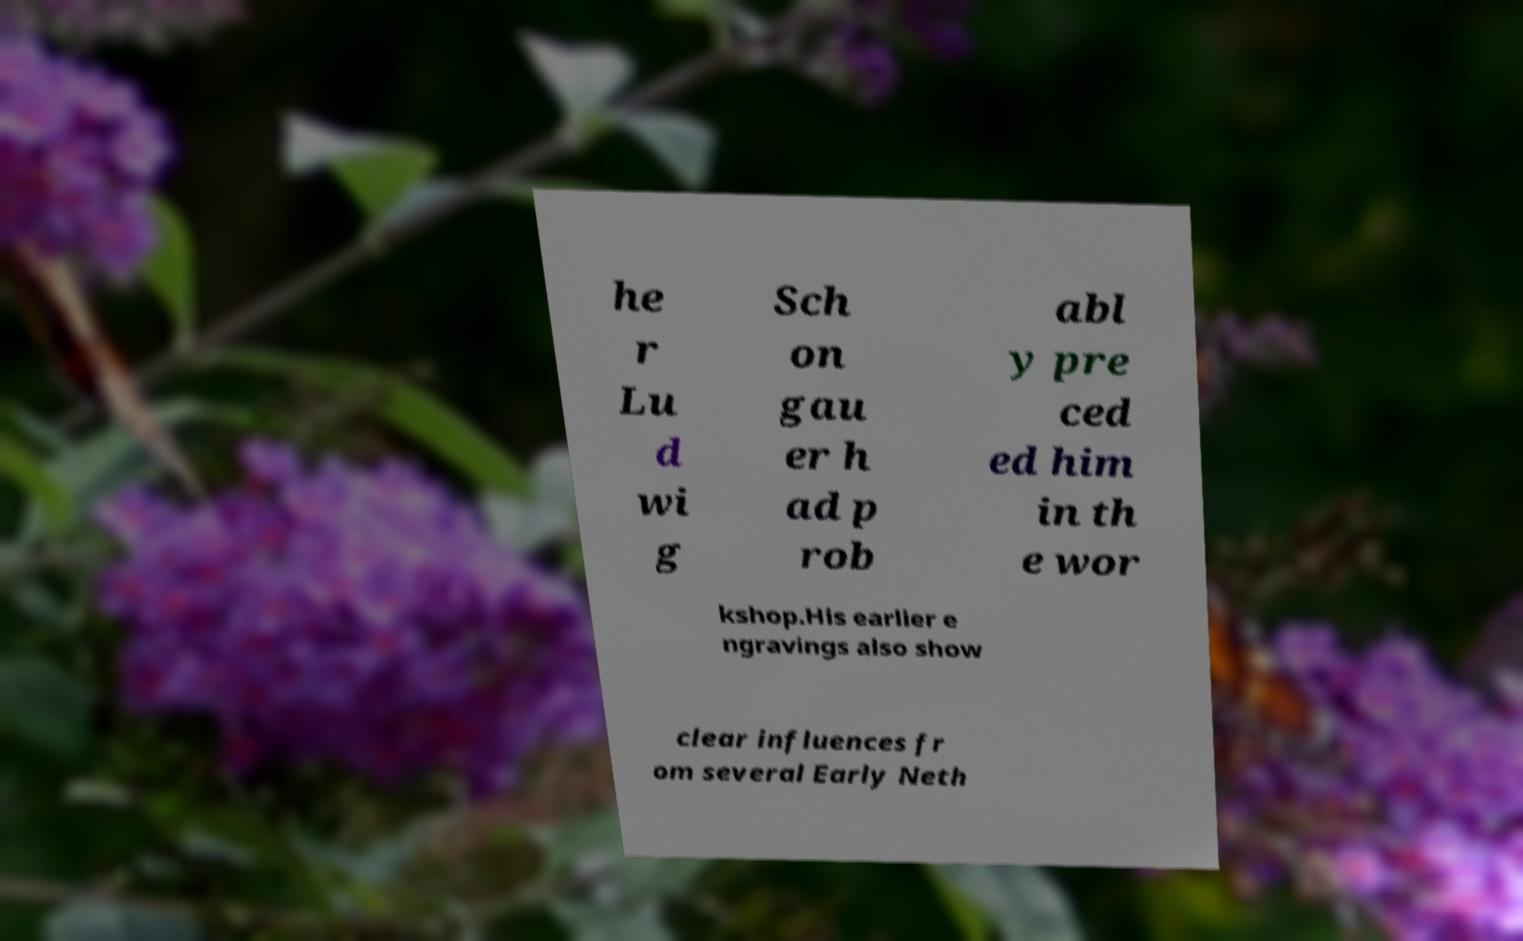Can you accurately transcribe the text from the provided image for me? he r Lu d wi g Sch on gau er h ad p rob abl y pre ced ed him in th e wor kshop.His earlier e ngravings also show clear influences fr om several Early Neth 